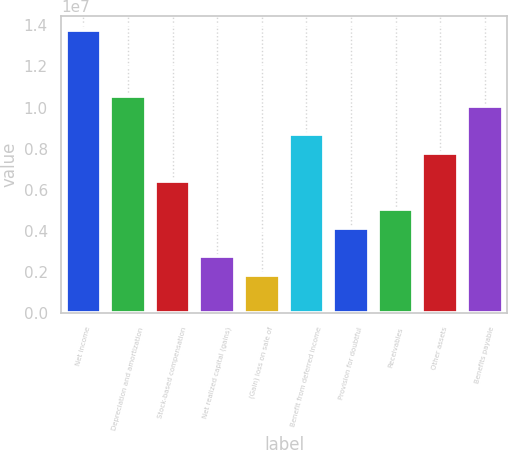Convert chart. <chart><loc_0><loc_0><loc_500><loc_500><bar_chart><fcel>Net income<fcel>Depreciation and amortization<fcel>Stock-based compensation<fcel>Net realized capital (gains)<fcel>(Gain) loss on sale of<fcel>Benefit from deferred income<fcel>Provision for doubtful<fcel>Receivables<fcel>Other assets<fcel>Benefits payable<nl><fcel>1.3768e+07<fcel>1.05555e+07<fcel>6.42506e+06<fcel>2.7536e+06<fcel>1.83573e+06<fcel>8.71973e+06<fcel>4.1304e+06<fcel>5.04827e+06<fcel>7.80186e+06<fcel>1.00965e+07<nl></chart> 